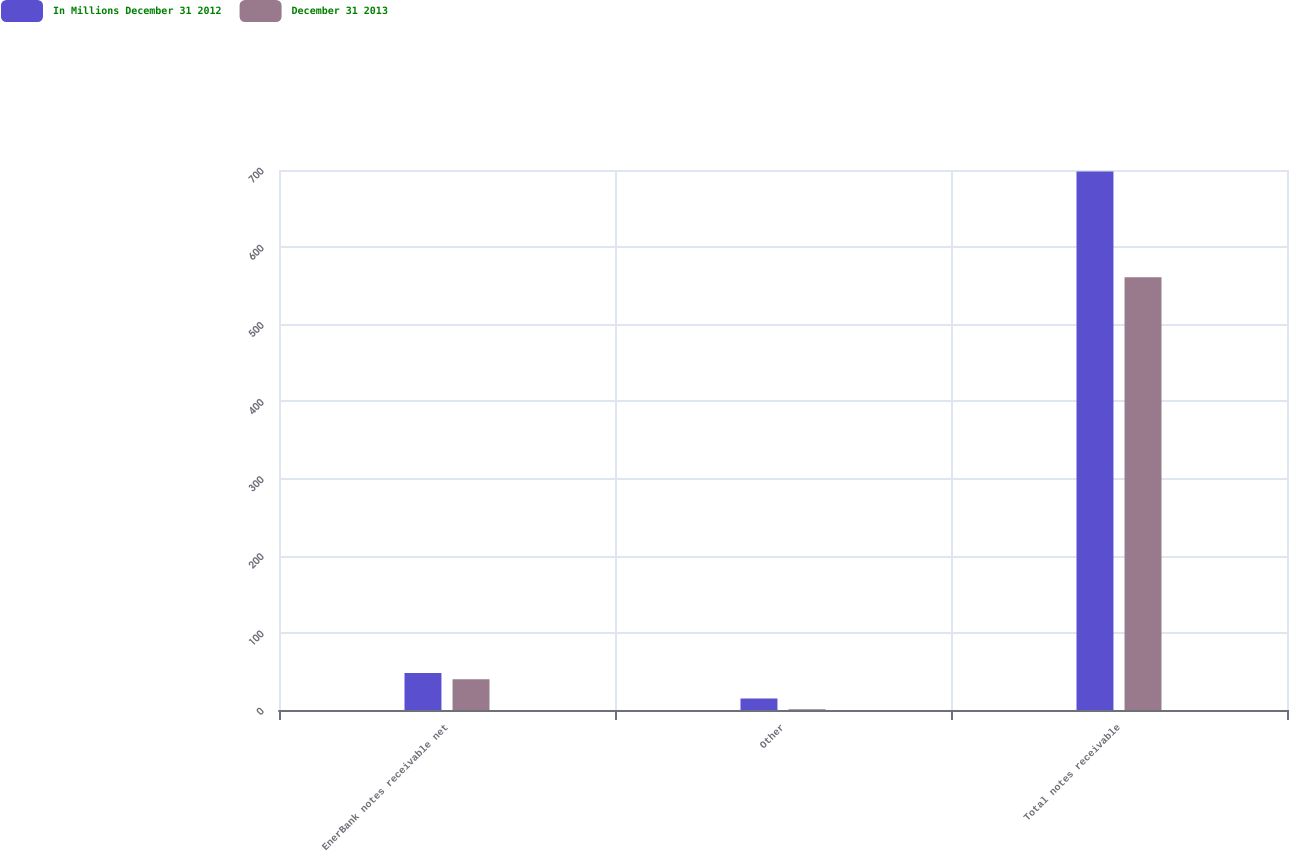Convert chart to OTSL. <chart><loc_0><loc_0><loc_500><loc_500><stacked_bar_chart><ecel><fcel>EnerBank notes receivable net<fcel>Other<fcel>Total notes receivable<nl><fcel>In Millions December 31 2012<fcel>48<fcel>15<fcel>698<nl><fcel>December 31 2013<fcel>40<fcel>1<fcel>561<nl></chart> 